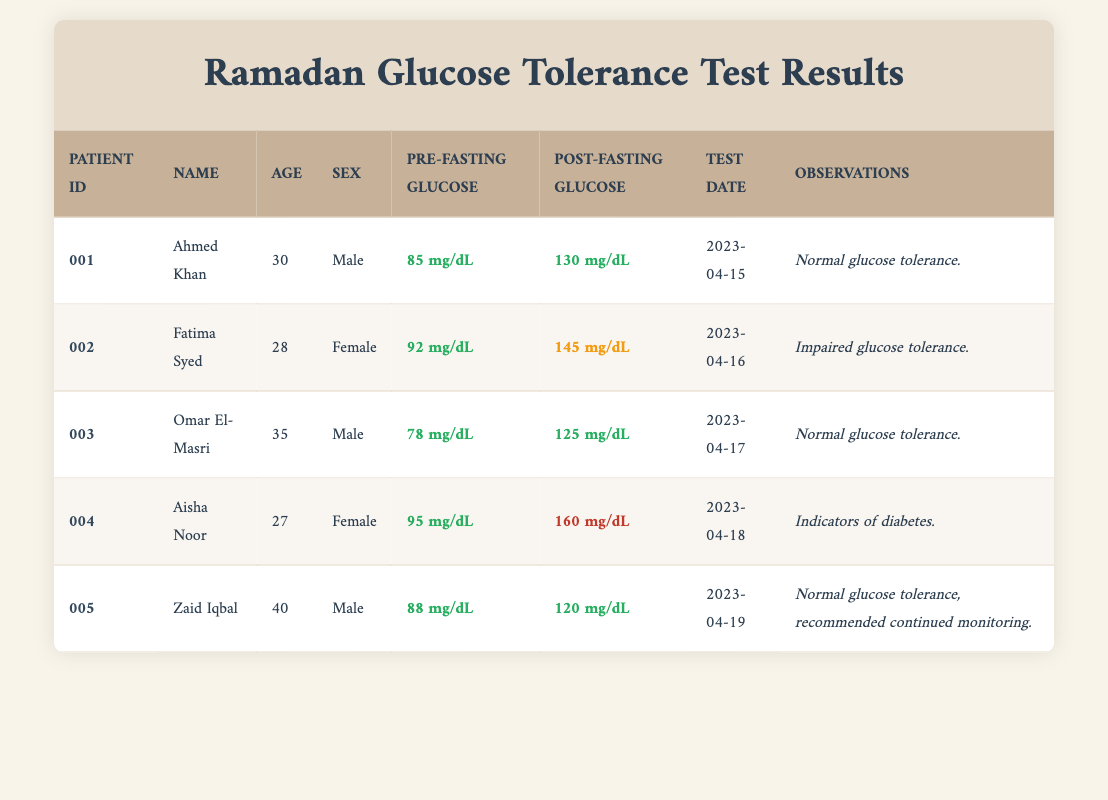What is the pre-fasting glucose level of Fatima Syed? According to the table, the pre-fasting glucose level for Fatima Syed is 92 mg/dL. This value is listed in the "Pre-Fasting Glucose" column for her row.
Answer: 92 mg/dL How many individuals show normal glucose tolerance? The individuals who show normal glucose tolerance are Ahmed Khan, Omar El-Masri, and Zaid Iqbal. Counting these names gives us a total of three individuals.
Answer: 3 What is the difference between the post-fasting glucose levels of Aisha Noor and Zaid Iqbal? The post-fasting glucose level for Aisha Noor is 160 mg/dL and for Zaid Iqbal is 120 mg/dL. The difference is calculated as 160 - 120 = 40 mg/dL.
Answer: 40 mg/dL Is there any indication of diabetes for Omar El-Masri? Looking at the observations column, Omar El-Masri's observation states "Normal glucose tolerance," which indicates that there are no signs of diabetes for him.
Answer: No What is the average pre-fasting glucose level for all individuals tested? The pre-fasting glucose values are 85, 92, 78, 95, and 88 mg/dL. Adding these gives 85 + 92 + 78 + 95 + 88 = 438 mg/dL. Since there are five individuals, the average is calculated as 438 / 5 = 87.6 mg/dL.
Answer: 87.6 mg/dL Which female patient has the highest post-fasting glucose level? The female patients in the table are Fatima Syed and Aisha Noor. Fatima has a post-fasting level of 145 mg/dL, while Aisha has a level of 160 mg/dL. Comparing these values, Aisha Noor has the highest level.
Answer: Aisha Noor How many male patients tested normal glucose tolerance? The male patients are Ahmed Khan, Omar El-Masri, and Zaid Iqbal. Among them, both Ahmed and Omar have normal glucose tolerance based on the observations, so there are two males with normal tolerance.
Answer: 2 Is the post-fasting glucose level for any patient classified as indicative of diabetes? Yes, according to the observations, Aisha Noor has a post-fasting glucose level of 160 mg/dL, which is classified as indicators of diabetes. This is explicitly stated in the observations column.
Answer: Yes 